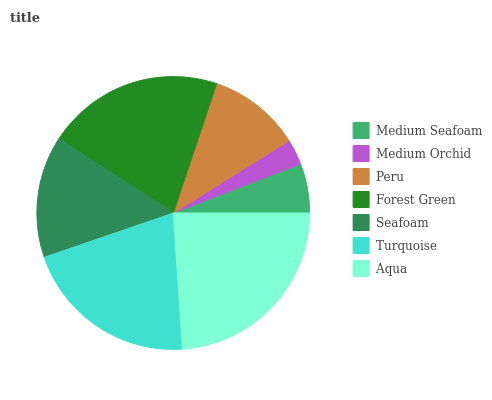Is Medium Orchid the minimum?
Answer yes or no. Yes. Is Aqua the maximum?
Answer yes or no. Yes. Is Peru the minimum?
Answer yes or no. No. Is Peru the maximum?
Answer yes or no. No. Is Peru greater than Medium Orchid?
Answer yes or no. Yes. Is Medium Orchid less than Peru?
Answer yes or no. Yes. Is Medium Orchid greater than Peru?
Answer yes or no. No. Is Peru less than Medium Orchid?
Answer yes or no. No. Is Seafoam the high median?
Answer yes or no. Yes. Is Seafoam the low median?
Answer yes or no. Yes. Is Peru the high median?
Answer yes or no. No. Is Medium Seafoam the low median?
Answer yes or no. No. 